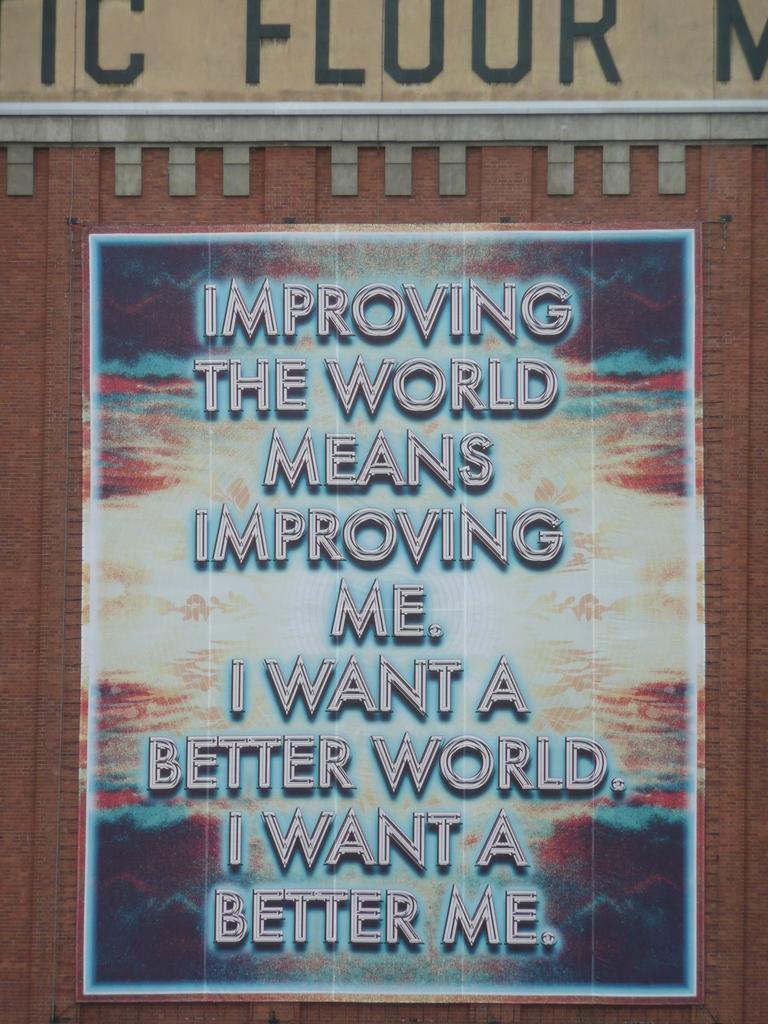What does the sign say?
Give a very brief answer. Improving the world means improving me. i want a better world. i want a better me. What word is visible above the sign?
Offer a very short reply. Floor. 